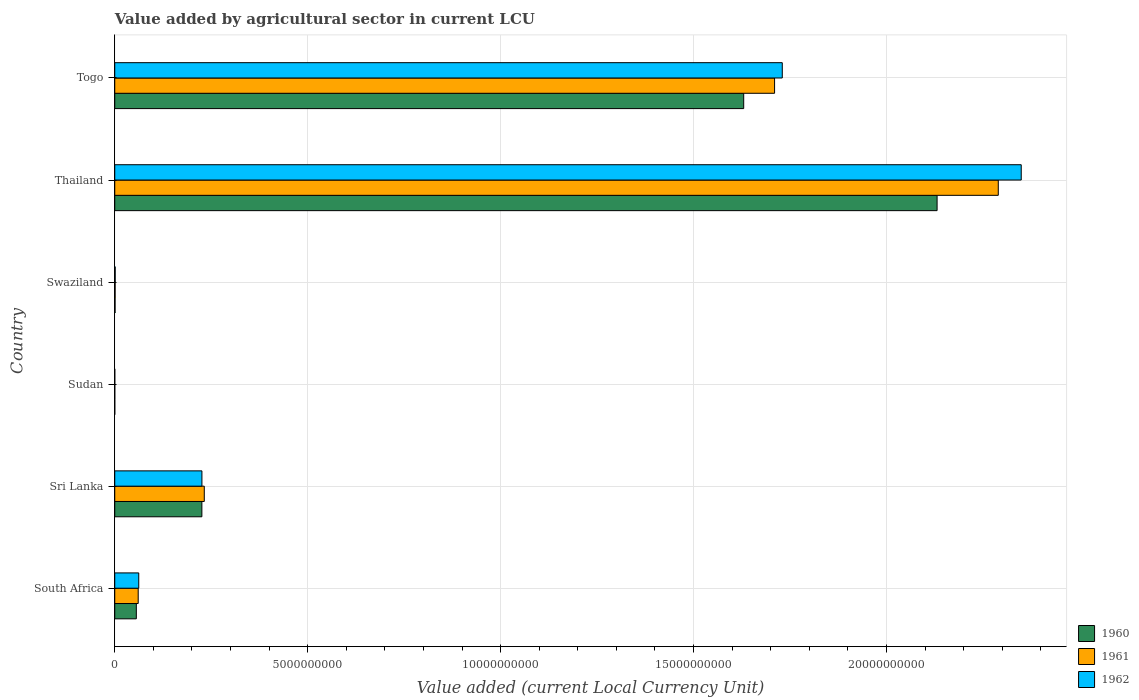Are the number of bars per tick equal to the number of legend labels?
Your response must be concise. Yes. Are the number of bars on each tick of the Y-axis equal?
Provide a succinct answer. Yes. How many bars are there on the 3rd tick from the top?
Your answer should be very brief. 3. What is the label of the 3rd group of bars from the top?
Offer a terse response. Swaziland. What is the value added by agricultural sector in 1960 in Togo?
Your response must be concise. 1.63e+1. Across all countries, what is the maximum value added by agricultural sector in 1961?
Your answer should be compact. 2.29e+1. Across all countries, what is the minimum value added by agricultural sector in 1960?
Your response must be concise. 2.02e+05. In which country was the value added by agricultural sector in 1961 maximum?
Offer a very short reply. Thailand. In which country was the value added by agricultural sector in 1961 minimum?
Provide a short and direct response. Sudan. What is the total value added by agricultural sector in 1962 in the graph?
Ensure brevity in your answer.  4.37e+1. What is the difference between the value added by agricultural sector in 1962 in Swaziland and that in Togo?
Your response must be concise. -1.73e+1. What is the difference between the value added by agricultural sector in 1962 in Sri Lanka and the value added by agricultural sector in 1960 in Thailand?
Ensure brevity in your answer.  -1.91e+1. What is the average value added by agricultural sector in 1962 per country?
Give a very brief answer. 7.28e+09. What is the difference between the value added by agricultural sector in 1960 and value added by agricultural sector in 1961 in Togo?
Offer a very short reply. -8.00e+08. What is the ratio of the value added by agricultural sector in 1960 in South Africa to that in Togo?
Provide a succinct answer. 0.03. Is the value added by agricultural sector in 1962 in South Africa less than that in Thailand?
Provide a succinct answer. Yes. What is the difference between the highest and the second highest value added by agricultural sector in 1961?
Ensure brevity in your answer.  5.80e+09. What is the difference between the highest and the lowest value added by agricultural sector in 1960?
Your response must be concise. 2.13e+1. In how many countries, is the value added by agricultural sector in 1962 greater than the average value added by agricultural sector in 1962 taken over all countries?
Provide a short and direct response. 2. What does the 3rd bar from the top in Togo represents?
Ensure brevity in your answer.  1960. Is it the case that in every country, the sum of the value added by agricultural sector in 1960 and value added by agricultural sector in 1962 is greater than the value added by agricultural sector in 1961?
Your answer should be compact. Yes. Are the values on the major ticks of X-axis written in scientific E-notation?
Offer a terse response. No. Does the graph contain grids?
Make the answer very short. Yes. What is the title of the graph?
Make the answer very short. Value added by agricultural sector in current LCU. Does "2010" appear as one of the legend labels in the graph?
Your answer should be compact. No. What is the label or title of the X-axis?
Give a very brief answer. Value added (current Local Currency Unit). What is the Value added (current Local Currency Unit) in 1960 in South Africa?
Your answer should be compact. 5.59e+08. What is the Value added (current Local Currency Unit) of 1961 in South Africa?
Provide a succinct answer. 6.08e+08. What is the Value added (current Local Currency Unit) of 1962 in South Africa?
Offer a terse response. 6.22e+08. What is the Value added (current Local Currency Unit) of 1960 in Sri Lanka?
Your answer should be very brief. 2.26e+09. What is the Value added (current Local Currency Unit) of 1961 in Sri Lanka?
Keep it short and to the point. 2.32e+09. What is the Value added (current Local Currency Unit) in 1962 in Sri Lanka?
Provide a succinct answer. 2.26e+09. What is the Value added (current Local Currency Unit) in 1960 in Sudan?
Provide a short and direct response. 2.02e+05. What is the Value added (current Local Currency Unit) of 1961 in Sudan?
Offer a terse response. 2.19e+05. What is the Value added (current Local Currency Unit) of 1962 in Sudan?
Keep it short and to the point. 2.31e+05. What is the Value added (current Local Currency Unit) of 1960 in Swaziland?
Your answer should be very brief. 7.90e+06. What is the Value added (current Local Currency Unit) of 1961 in Swaziland?
Keep it short and to the point. 9.30e+06. What is the Value added (current Local Currency Unit) in 1962 in Swaziland?
Your answer should be very brief. 1.14e+07. What is the Value added (current Local Currency Unit) in 1960 in Thailand?
Offer a very short reply. 2.13e+1. What is the Value added (current Local Currency Unit) in 1961 in Thailand?
Give a very brief answer. 2.29e+1. What is the Value added (current Local Currency Unit) of 1962 in Thailand?
Ensure brevity in your answer.  2.35e+1. What is the Value added (current Local Currency Unit) of 1960 in Togo?
Ensure brevity in your answer.  1.63e+1. What is the Value added (current Local Currency Unit) of 1961 in Togo?
Offer a very short reply. 1.71e+1. What is the Value added (current Local Currency Unit) in 1962 in Togo?
Your response must be concise. 1.73e+1. Across all countries, what is the maximum Value added (current Local Currency Unit) in 1960?
Offer a terse response. 2.13e+1. Across all countries, what is the maximum Value added (current Local Currency Unit) in 1961?
Your answer should be compact. 2.29e+1. Across all countries, what is the maximum Value added (current Local Currency Unit) in 1962?
Offer a very short reply. 2.35e+1. Across all countries, what is the minimum Value added (current Local Currency Unit) of 1960?
Your response must be concise. 2.02e+05. Across all countries, what is the minimum Value added (current Local Currency Unit) in 1961?
Give a very brief answer. 2.19e+05. Across all countries, what is the minimum Value added (current Local Currency Unit) in 1962?
Your answer should be compact. 2.31e+05. What is the total Value added (current Local Currency Unit) of 1960 in the graph?
Provide a short and direct response. 4.04e+1. What is the total Value added (current Local Currency Unit) of 1961 in the graph?
Your response must be concise. 4.29e+1. What is the total Value added (current Local Currency Unit) in 1962 in the graph?
Provide a succinct answer. 4.37e+1. What is the difference between the Value added (current Local Currency Unit) of 1960 in South Africa and that in Sri Lanka?
Ensure brevity in your answer.  -1.70e+09. What is the difference between the Value added (current Local Currency Unit) in 1961 in South Africa and that in Sri Lanka?
Provide a succinct answer. -1.71e+09. What is the difference between the Value added (current Local Currency Unit) in 1962 in South Africa and that in Sri Lanka?
Keep it short and to the point. -1.64e+09. What is the difference between the Value added (current Local Currency Unit) in 1960 in South Africa and that in Sudan?
Your answer should be compact. 5.59e+08. What is the difference between the Value added (current Local Currency Unit) of 1961 in South Africa and that in Sudan?
Offer a very short reply. 6.07e+08. What is the difference between the Value added (current Local Currency Unit) of 1962 in South Africa and that in Sudan?
Your answer should be compact. 6.21e+08. What is the difference between the Value added (current Local Currency Unit) of 1960 in South Africa and that in Swaziland?
Keep it short and to the point. 5.51e+08. What is the difference between the Value added (current Local Currency Unit) of 1961 in South Africa and that in Swaziland?
Your answer should be compact. 5.98e+08. What is the difference between the Value added (current Local Currency Unit) in 1962 in South Africa and that in Swaziland?
Give a very brief answer. 6.10e+08. What is the difference between the Value added (current Local Currency Unit) of 1960 in South Africa and that in Thailand?
Make the answer very short. -2.08e+1. What is the difference between the Value added (current Local Currency Unit) of 1961 in South Africa and that in Thailand?
Provide a short and direct response. -2.23e+1. What is the difference between the Value added (current Local Currency Unit) of 1962 in South Africa and that in Thailand?
Offer a terse response. -2.29e+1. What is the difference between the Value added (current Local Currency Unit) in 1960 in South Africa and that in Togo?
Offer a very short reply. -1.57e+1. What is the difference between the Value added (current Local Currency Unit) in 1961 in South Africa and that in Togo?
Provide a short and direct response. -1.65e+1. What is the difference between the Value added (current Local Currency Unit) of 1962 in South Africa and that in Togo?
Make the answer very short. -1.67e+1. What is the difference between the Value added (current Local Currency Unit) in 1960 in Sri Lanka and that in Sudan?
Offer a very short reply. 2.26e+09. What is the difference between the Value added (current Local Currency Unit) of 1961 in Sri Lanka and that in Sudan?
Ensure brevity in your answer.  2.32e+09. What is the difference between the Value added (current Local Currency Unit) of 1962 in Sri Lanka and that in Sudan?
Ensure brevity in your answer.  2.26e+09. What is the difference between the Value added (current Local Currency Unit) in 1960 in Sri Lanka and that in Swaziland?
Offer a terse response. 2.25e+09. What is the difference between the Value added (current Local Currency Unit) of 1961 in Sri Lanka and that in Swaziland?
Your answer should be very brief. 2.31e+09. What is the difference between the Value added (current Local Currency Unit) in 1962 in Sri Lanka and that in Swaziland?
Make the answer very short. 2.25e+09. What is the difference between the Value added (current Local Currency Unit) in 1960 in Sri Lanka and that in Thailand?
Provide a short and direct response. -1.91e+1. What is the difference between the Value added (current Local Currency Unit) of 1961 in Sri Lanka and that in Thailand?
Provide a succinct answer. -2.06e+1. What is the difference between the Value added (current Local Currency Unit) of 1962 in Sri Lanka and that in Thailand?
Keep it short and to the point. -2.12e+1. What is the difference between the Value added (current Local Currency Unit) in 1960 in Sri Lanka and that in Togo?
Offer a very short reply. -1.40e+1. What is the difference between the Value added (current Local Currency Unit) in 1961 in Sri Lanka and that in Togo?
Your answer should be very brief. -1.48e+1. What is the difference between the Value added (current Local Currency Unit) in 1962 in Sri Lanka and that in Togo?
Offer a terse response. -1.50e+1. What is the difference between the Value added (current Local Currency Unit) of 1960 in Sudan and that in Swaziland?
Offer a terse response. -7.70e+06. What is the difference between the Value added (current Local Currency Unit) in 1961 in Sudan and that in Swaziland?
Give a very brief answer. -9.08e+06. What is the difference between the Value added (current Local Currency Unit) of 1962 in Sudan and that in Swaziland?
Keep it short and to the point. -1.12e+07. What is the difference between the Value added (current Local Currency Unit) of 1960 in Sudan and that in Thailand?
Your response must be concise. -2.13e+1. What is the difference between the Value added (current Local Currency Unit) of 1961 in Sudan and that in Thailand?
Provide a short and direct response. -2.29e+1. What is the difference between the Value added (current Local Currency Unit) in 1962 in Sudan and that in Thailand?
Offer a very short reply. -2.35e+1. What is the difference between the Value added (current Local Currency Unit) in 1960 in Sudan and that in Togo?
Give a very brief answer. -1.63e+1. What is the difference between the Value added (current Local Currency Unit) of 1961 in Sudan and that in Togo?
Ensure brevity in your answer.  -1.71e+1. What is the difference between the Value added (current Local Currency Unit) in 1962 in Sudan and that in Togo?
Keep it short and to the point. -1.73e+1. What is the difference between the Value added (current Local Currency Unit) of 1960 in Swaziland and that in Thailand?
Give a very brief answer. -2.13e+1. What is the difference between the Value added (current Local Currency Unit) in 1961 in Swaziland and that in Thailand?
Your answer should be compact. -2.29e+1. What is the difference between the Value added (current Local Currency Unit) of 1962 in Swaziland and that in Thailand?
Ensure brevity in your answer.  -2.35e+1. What is the difference between the Value added (current Local Currency Unit) of 1960 in Swaziland and that in Togo?
Offer a terse response. -1.63e+1. What is the difference between the Value added (current Local Currency Unit) in 1961 in Swaziland and that in Togo?
Ensure brevity in your answer.  -1.71e+1. What is the difference between the Value added (current Local Currency Unit) in 1962 in Swaziland and that in Togo?
Ensure brevity in your answer.  -1.73e+1. What is the difference between the Value added (current Local Currency Unit) in 1960 in Thailand and that in Togo?
Your answer should be very brief. 5.01e+09. What is the difference between the Value added (current Local Currency Unit) of 1961 in Thailand and that in Togo?
Provide a succinct answer. 5.80e+09. What is the difference between the Value added (current Local Currency Unit) in 1962 in Thailand and that in Togo?
Offer a terse response. 6.19e+09. What is the difference between the Value added (current Local Currency Unit) in 1960 in South Africa and the Value added (current Local Currency Unit) in 1961 in Sri Lanka?
Provide a succinct answer. -1.76e+09. What is the difference between the Value added (current Local Currency Unit) of 1960 in South Africa and the Value added (current Local Currency Unit) of 1962 in Sri Lanka?
Your answer should be very brief. -1.70e+09. What is the difference between the Value added (current Local Currency Unit) in 1961 in South Africa and the Value added (current Local Currency Unit) in 1962 in Sri Lanka?
Offer a very short reply. -1.65e+09. What is the difference between the Value added (current Local Currency Unit) of 1960 in South Africa and the Value added (current Local Currency Unit) of 1961 in Sudan?
Provide a succinct answer. 5.59e+08. What is the difference between the Value added (current Local Currency Unit) of 1960 in South Africa and the Value added (current Local Currency Unit) of 1962 in Sudan?
Your response must be concise. 5.59e+08. What is the difference between the Value added (current Local Currency Unit) in 1961 in South Africa and the Value added (current Local Currency Unit) in 1962 in Sudan?
Offer a terse response. 6.07e+08. What is the difference between the Value added (current Local Currency Unit) in 1960 in South Africa and the Value added (current Local Currency Unit) in 1961 in Swaziland?
Provide a short and direct response. 5.50e+08. What is the difference between the Value added (current Local Currency Unit) of 1960 in South Africa and the Value added (current Local Currency Unit) of 1962 in Swaziland?
Provide a short and direct response. 5.48e+08. What is the difference between the Value added (current Local Currency Unit) in 1961 in South Africa and the Value added (current Local Currency Unit) in 1962 in Swaziland?
Your answer should be very brief. 5.96e+08. What is the difference between the Value added (current Local Currency Unit) in 1960 in South Africa and the Value added (current Local Currency Unit) in 1961 in Thailand?
Offer a very short reply. -2.23e+1. What is the difference between the Value added (current Local Currency Unit) of 1960 in South Africa and the Value added (current Local Currency Unit) of 1962 in Thailand?
Offer a terse response. -2.29e+1. What is the difference between the Value added (current Local Currency Unit) of 1961 in South Africa and the Value added (current Local Currency Unit) of 1962 in Thailand?
Make the answer very short. -2.29e+1. What is the difference between the Value added (current Local Currency Unit) in 1960 in South Africa and the Value added (current Local Currency Unit) in 1961 in Togo?
Your response must be concise. -1.65e+1. What is the difference between the Value added (current Local Currency Unit) of 1960 in South Africa and the Value added (current Local Currency Unit) of 1962 in Togo?
Keep it short and to the point. -1.67e+1. What is the difference between the Value added (current Local Currency Unit) of 1961 in South Africa and the Value added (current Local Currency Unit) of 1962 in Togo?
Keep it short and to the point. -1.67e+1. What is the difference between the Value added (current Local Currency Unit) of 1960 in Sri Lanka and the Value added (current Local Currency Unit) of 1961 in Sudan?
Keep it short and to the point. 2.26e+09. What is the difference between the Value added (current Local Currency Unit) in 1960 in Sri Lanka and the Value added (current Local Currency Unit) in 1962 in Sudan?
Give a very brief answer. 2.26e+09. What is the difference between the Value added (current Local Currency Unit) of 1961 in Sri Lanka and the Value added (current Local Currency Unit) of 1962 in Sudan?
Your response must be concise. 2.32e+09. What is the difference between the Value added (current Local Currency Unit) in 1960 in Sri Lanka and the Value added (current Local Currency Unit) in 1961 in Swaziland?
Offer a very short reply. 2.25e+09. What is the difference between the Value added (current Local Currency Unit) in 1960 in Sri Lanka and the Value added (current Local Currency Unit) in 1962 in Swaziland?
Your answer should be compact. 2.25e+09. What is the difference between the Value added (current Local Currency Unit) in 1961 in Sri Lanka and the Value added (current Local Currency Unit) in 1962 in Swaziland?
Your response must be concise. 2.31e+09. What is the difference between the Value added (current Local Currency Unit) of 1960 in Sri Lanka and the Value added (current Local Currency Unit) of 1961 in Thailand?
Provide a short and direct response. -2.06e+1. What is the difference between the Value added (current Local Currency Unit) in 1960 in Sri Lanka and the Value added (current Local Currency Unit) in 1962 in Thailand?
Provide a short and direct response. -2.12e+1. What is the difference between the Value added (current Local Currency Unit) in 1961 in Sri Lanka and the Value added (current Local Currency Unit) in 1962 in Thailand?
Provide a succinct answer. -2.12e+1. What is the difference between the Value added (current Local Currency Unit) in 1960 in Sri Lanka and the Value added (current Local Currency Unit) in 1961 in Togo?
Offer a very short reply. -1.48e+1. What is the difference between the Value added (current Local Currency Unit) of 1960 in Sri Lanka and the Value added (current Local Currency Unit) of 1962 in Togo?
Your response must be concise. -1.50e+1. What is the difference between the Value added (current Local Currency Unit) of 1961 in Sri Lanka and the Value added (current Local Currency Unit) of 1962 in Togo?
Provide a short and direct response. -1.50e+1. What is the difference between the Value added (current Local Currency Unit) in 1960 in Sudan and the Value added (current Local Currency Unit) in 1961 in Swaziland?
Offer a very short reply. -9.10e+06. What is the difference between the Value added (current Local Currency Unit) of 1960 in Sudan and the Value added (current Local Currency Unit) of 1962 in Swaziland?
Make the answer very short. -1.12e+07. What is the difference between the Value added (current Local Currency Unit) in 1961 in Sudan and the Value added (current Local Currency Unit) in 1962 in Swaziland?
Offer a terse response. -1.12e+07. What is the difference between the Value added (current Local Currency Unit) in 1960 in Sudan and the Value added (current Local Currency Unit) in 1961 in Thailand?
Make the answer very short. -2.29e+1. What is the difference between the Value added (current Local Currency Unit) in 1960 in Sudan and the Value added (current Local Currency Unit) in 1962 in Thailand?
Offer a terse response. -2.35e+1. What is the difference between the Value added (current Local Currency Unit) in 1961 in Sudan and the Value added (current Local Currency Unit) in 1962 in Thailand?
Keep it short and to the point. -2.35e+1. What is the difference between the Value added (current Local Currency Unit) in 1960 in Sudan and the Value added (current Local Currency Unit) in 1961 in Togo?
Your answer should be very brief. -1.71e+1. What is the difference between the Value added (current Local Currency Unit) in 1960 in Sudan and the Value added (current Local Currency Unit) in 1962 in Togo?
Provide a short and direct response. -1.73e+1. What is the difference between the Value added (current Local Currency Unit) of 1961 in Sudan and the Value added (current Local Currency Unit) of 1962 in Togo?
Provide a succinct answer. -1.73e+1. What is the difference between the Value added (current Local Currency Unit) of 1960 in Swaziland and the Value added (current Local Currency Unit) of 1961 in Thailand?
Offer a very short reply. -2.29e+1. What is the difference between the Value added (current Local Currency Unit) in 1960 in Swaziland and the Value added (current Local Currency Unit) in 1962 in Thailand?
Provide a short and direct response. -2.35e+1. What is the difference between the Value added (current Local Currency Unit) of 1961 in Swaziland and the Value added (current Local Currency Unit) of 1962 in Thailand?
Offer a terse response. -2.35e+1. What is the difference between the Value added (current Local Currency Unit) of 1960 in Swaziland and the Value added (current Local Currency Unit) of 1961 in Togo?
Make the answer very short. -1.71e+1. What is the difference between the Value added (current Local Currency Unit) in 1960 in Swaziland and the Value added (current Local Currency Unit) in 1962 in Togo?
Offer a terse response. -1.73e+1. What is the difference between the Value added (current Local Currency Unit) of 1961 in Swaziland and the Value added (current Local Currency Unit) of 1962 in Togo?
Keep it short and to the point. -1.73e+1. What is the difference between the Value added (current Local Currency Unit) of 1960 in Thailand and the Value added (current Local Currency Unit) of 1961 in Togo?
Keep it short and to the point. 4.21e+09. What is the difference between the Value added (current Local Currency Unit) in 1960 in Thailand and the Value added (current Local Currency Unit) in 1962 in Togo?
Provide a short and direct response. 4.01e+09. What is the difference between the Value added (current Local Currency Unit) of 1961 in Thailand and the Value added (current Local Currency Unit) of 1962 in Togo?
Keep it short and to the point. 5.60e+09. What is the average Value added (current Local Currency Unit) in 1960 per country?
Offer a terse response. 6.74e+09. What is the average Value added (current Local Currency Unit) of 1961 per country?
Your response must be concise. 7.16e+09. What is the average Value added (current Local Currency Unit) of 1962 per country?
Provide a short and direct response. 7.28e+09. What is the difference between the Value added (current Local Currency Unit) in 1960 and Value added (current Local Currency Unit) in 1961 in South Africa?
Your answer should be compact. -4.85e+07. What is the difference between the Value added (current Local Currency Unit) of 1960 and Value added (current Local Currency Unit) of 1962 in South Africa?
Give a very brief answer. -6.25e+07. What is the difference between the Value added (current Local Currency Unit) in 1961 and Value added (current Local Currency Unit) in 1962 in South Africa?
Offer a terse response. -1.40e+07. What is the difference between the Value added (current Local Currency Unit) in 1960 and Value added (current Local Currency Unit) in 1961 in Sri Lanka?
Provide a short and direct response. -6.20e+07. What is the difference between the Value added (current Local Currency Unit) in 1961 and Value added (current Local Currency Unit) in 1962 in Sri Lanka?
Ensure brevity in your answer.  6.10e+07. What is the difference between the Value added (current Local Currency Unit) in 1960 and Value added (current Local Currency Unit) in 1961 in Sudan?
Provide a short and direct response. -1.76e+04. What is the difference between the Value added (current Local Currency Unit) in 1960 and Value added (current Local Currency Unit) in 1962 in Sudan?
Offer a very short reply. -2.90e+04. What is the difference between the Value added (current Local Currency Unit) in 1961 and Value added (current Local Currency Unit) in 1962 in Sudan?
Your answer should be compact. -1.14e+04. What is the difference between the Value added (current Local Currency Unit) of 1960 and Value added (current Local Currency Unit) of 1961 in Swaziland?
Your answer should be compact. -1.40e+06. What is the difference between the Value added (current Local Currency Unit) of 1960 and Value added (current Local Currency Unit) of 1962 in Swaziland?
Offer a terse response. -3.50e+06. What is the difference between the Value added (current Local Currency Unit) in 1961 and Value added (current Local Currency Unit) in 1962 in Swaziland?
Ensure brevity in your answer.  -2.10e+06. What is the difference between the Value added (current Local Currency Unit) in 1960 and Value added (current Local Currency Unit) in 1961 in Thailand?
Provide a succinct answer. -1.59e+09. What is the difference between the Value added (current Local Currency Unit) in 1960 and Value added (current Local Currency Unit) in 1962 in Thailand?
Offer a very short reply. -2.18e+09. What is the difference between the Value added (current Local Currency Unit) in 1961 and Value added (current Local Currency Unit) in 1962 in Thailand?
Ensure brevity in your answer.  -5.95e+08. What is the difference between the Value added (current Local Currency Unit) of 1960 and Value added (current Local Currency Unit) of 1961 in Togo?
Your response must be concise. -8.00e+08. What is the difference between the Value added (current Local Currency Unit) of 1960 and Value added (current Local Currency Unit) of 1962 in Togo?
Keep it short and to the point. -1.00e+09. What is the difference between the Value added (current Local Currency Unit) in 1961 and Value added (current Local Currency Unit) in 1962 in Togo?
Your answer should be very brief. -2.00e+08. What is the ratio of the Value added (current Local Currency Unit) in 1960 in South Africa to that in Sri Lanka?
Your response must be concise. 0.25. What is the ratio of the Value added (current Local Currency Unit) in 1961 in South Africa to that in Sri Lanka?
Ensure brevity in your answer.  0.26. What is the ratio of the Value added (current Local Currency Unit) in 1962 in South Africa to that in Sri Lanka?
Your answer should be very brief. 0.28. What is the ratio of the Value added (current Local Currency Unit) of 1960 in South Africa to that in Sudan?
Provide a succinct answer. 2772.04. What is the ratio of the Value added (current Local Currency Unit) of 1961 in South Africa to that in Sudan?
Make the answer very short. 2770.9. What is the ratio of the Value added (current Local Currency Unit) of 1962 in South Africa to that in Sudan?
Keep it short and to the point. 2694.67. What is the ratio of the Value added (current Local Currency Unit) of 1960 in South Africa to that in Swaziland?
Give a very brief answer. 70.77. What is the ratio of the Value added (current Local Currency Unit) in 1961 in South Africa to that in Swaziland?
Provide a succinct answer. 65.34. What is the ratio of the Value added (current Local Currency Unit) of 1962 in South Africa to that in Swaziland?
Give a very brief answer. 54.53. What is the ratio of the Value added (current Local Currency Unit) of 1960 in South Africa to that in Thailand?
Ensure brevity in your answer.  0.03. What is the ratio of the Value added (current Local Currency Unit) of 1961 in South Africa to that in Thailand?
Keep it short and to the point. 0.03. What is the ratio of the Value added (current Local Currency Unit) of 1962 in South Africa to that in Thailand?
Provide a succinct answer. 0.03. What is the ratio of the Value added (current Local Currency Unit) of 1960 in South Africa to that in Togo?
Offer a terse response. 0.03. What is the ratio of the Value added (current Local Currency Unit) in 1961 in South Africa to that in Togo?
Offer a very short reply. 0.04. What is the ratio of the Value added (current Local Currency Unit) of 1962 in South Africa to that in Togo?
Your response must be concise. 0.04. What is the ratio of the Value added (current Local Currency Unit) in 1960 in Sri Lanka to that in Sudan?
Offer a terse response. 1.12e+04. What is the ratio of the Value added (current Local Currency Unit) of 1961 in Sri Lanka to that in Sudan?
Provide a short and direct response. 1.06e+04. What is the ratio of the Value added (current Local Currency Unit) of 1962 in Sri Lanka to that in Sudan?
Offer a terse response. 9791.94. What is the ratio of the Value added (current Local Currency Unit) in 1960 in Sri Lanka to that in Swaziland?
Offer a very short reply. 285.82. What is the ratio of the Value added (current Local Currency Unit) in 1961 in Sri Lanka to that in Swaziland?
Ensure brevity in your answer.  249.46. What is the ratio of the Value added (current Local Currency Unit) in 1962 in Sri Lanka to that in Swaziland?
Offer a very short reply. 198.16. What is the ratio of the Value added (current Local Currency Unit) of 1960 in Sri Lanka to that in Thailand?
Keep it short and to the point. 0.11. What is the ratio of the Value added (current Local Currency Unit) in 1961 in Sri Lanka to that in Thailand?
Make the answer very short. 0.1. What is the ratio of the Value added (current Local Currency Unit) in 1962 in Sri Lanka to that in Thailand?
Offer a terse response. 0.1. What is the ratio of the Value added (current Local Currency Unit) in 1960 in Sri Lanka to that in Togo?
Your answer should be compact. 0.14. What is the ratio of the Value added (current Local Currency Unit) of 1961 in Sri Lanka to that in Togo?
Keep it short and to the point. 0.14. What is the ratio of the Value added (current Local Currency Unit) of 1962 in Sri Lanka to that in Togo?
Provide a succinct answer. 0.13. What is the ratio of the Value added (current Local Currency Unit) of 1960 in Sudan to that in Swaziland?
Provide a short and direct response. 0.03. What is the ratio of the Value added (current Local Currency Unit) of 1961 in Sudan to that in Swaziland?
Your answer should be compact. 0.02. What is the ratio of the Value added (current Local Currency Unit) of 1962 in Sudan to that in Swaziland?
Make the answer very short. 0.02. What is the ratio of the Value added (current Local Currency Unit) of 1960 in Sudan to that in Thailand?
Keep it short and to the point. 0. What is the ratio of the Value added (current Local Currency Unit) in 1961 in Sudan to that in Thailand?
Offer a very short reply. 0. What is the ratio of the Value added (current Local Currency Unit) of 1962 in Sudan to that in Thailand?
Give a very brief answer. 0. What is the ratio of the Value added (current Local Currency Unit) in 1960 in Sudan to that in Togo?
Offer a terse response. 0. What is the ratio of the Value added (current Local Currency Unit) in 1961 in Sudan to that in Togo?
Make the answer very short. 0. What is the ratio of the Value added (current Local Currency Unit) of 1962 in Sudan to that in Togo?
Your response must be concise. 0. What is the ratio of the Value added (current Local Currency Unit) of 1961 in Swaziland to that in Thailand?
Make the answer very short. 0. What is the ratio of the Value added (current Local Currency Unit) in 1962 in Swaziland to that in Thailand?
Your answer should be very brief. 0. What is the ratio of the Value added (current Local Currency Unit) in 1960 in Swaziland to that in Togo?
Give a very brief answer. 0. What is the ratio of the Value added (current Local Currency Unit) of 1961 in Swaziland to that in Togo?
Offer a very short reply. 0. What is the ratio of the Value added (current Local Currency Unit) in 1962 in Swaziland to that in Togo?
Provide a succinct answer. 0. What is the ratio of the Value added (current Local Currency Unit) in 1960 in Thailand to that in Togo?
Provide a succinct answer. 1.31. What is the ratio of the Value added (current Local Currency Unit) in 1961 in Thailand to that in Togo?
Ensure brevity in your answer.  1.34. What is the ratio of the Value added (current Local Currency Unit) of 1962 in Thailand to that in Togo?
Offer a very short reply. 1.36. What is the difference between the highest and the second highest Value added (current Local Currency Unit) of 1960?
Offer a terse response. 5.01e+09. What is the difference between the highest and the second highest Value added (current Local Currency Unit) of 1961?
Ensure brevity in your answer.  5.80e+09. What is the difference between the highest and the second highest Value added (current Local Currency Unit) of 1962?
Make the answer very short. 6.19e+09. What is the difference between the highest and the lowest Value added (current Local Currency Unit) of 1960?
Keep it short and to the point. 2.13e+1. What is the difference between the highest and the lowest Value added (current Local Currency Unit) in 1961?
Provide a succinct answer. 2.29e+1. What is the difference between the highest and the lowest Value added (current Local Currency Unit) of 1962?
Provide a short and direct response. 2.35e+1. 